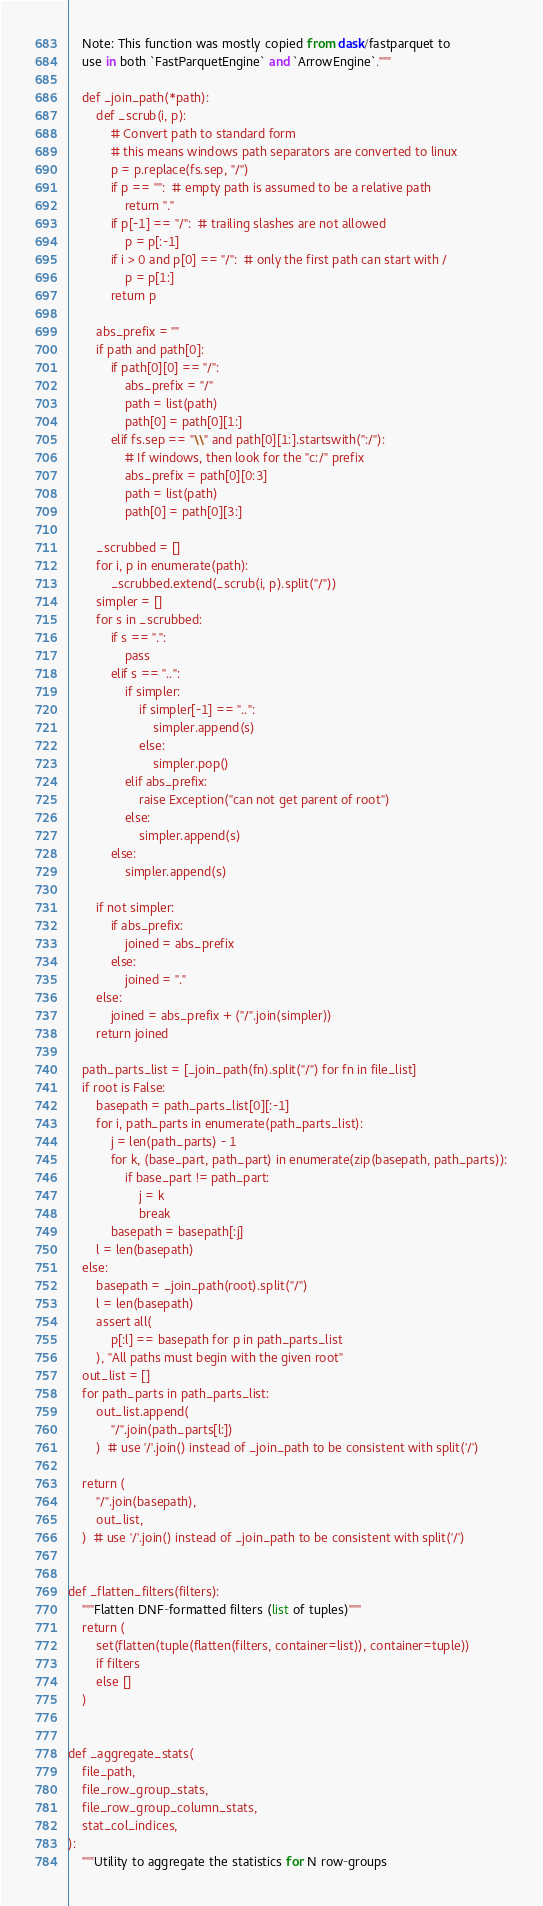Convert code to text. <code><loc_0><loc_0><loc_500><loc_500><_Python_>    Note: This function was mostly copied from dask/fastparquet to
    use in both `FastParquetEngine` and `ArrowEngine`."""

    def _join_path(*path):
        def _scrub(i, p):
            # Convert path to standard form
            # this means windows path separators are converted to linux
            p = p.replace(fs.sep, "/")
            if p == "":  # empty path is assumed to be a relative path
                return "."
            if p[-1] == "/":  # trailing slashes are not allowed
                p = p[:-1]
            if i > 0 and p[0] == "/":  # only the first path can start with /
                p = p[1:]
            return p

        abs_prefix = ""
        if path and path[0]:
            if path[0][0] == "/":
                abs_prefix = "/"
                path = list(path)
                path[0] = path[0][1:]
            elif fs.sep == "\\" and path[0][1:].startswith(":/"):
                # If windows, then look for the "c:/" prefix
                abs_prefix = path[0][0:3]
                path = list(path)
                path[0] = path[0][3:]

        _scrubbed = []
        for i, p in enumerate(path):
            _scrubbed.extend(_scrub(i, p).split("/"))
        simpler = []
        for s in _scrubbed:
            if s == ".":
                pass
            elif s == "..":
                if simpler:
                    if simpler[-1] == "..":
                        simpler.append(s)
                    else:
                        simpler.pop()
                elif abs_prefix:
                    raise Exception("can not get parent of root")
                else:
                    simpler.append(s)
            else:
                simpler.append(s)

        if not simpler:
            if abs_prefix:
                joined = abs_prefix
            else:
                joined = "."
        else:
            joined = abs_prefix + ("/".join(simpler))
        return joined

    path_parts_list = [_join_path(fn).split("/") for fn in file_list]
    if root is False:
        basepath = path_parts_list[0][:-1]
        for i, path_parts in enumerate(path_parts_list):
            j = len(path_parts) - 1
            for k, (base_part, path_part) in enumerate(zip(basepath, path_parts)):
                if base_part != path_part:
                    j = k
                    break
            basepath = basepath[:j]
        l = len(basepath)
    else:
        basepath = _join_path(root).split("/")
        l = len(basepath)
        assert all(
            p[:l] == basepath for p in path_parts_list
        ), "All paths must begin with the given root"
    out_list = []
    for path_parts in path_parts_list:
        out_list.append(
            "/".join(path_parts[l:])
        )  # use '/'.join() instead of _join_path to be consistent with split('/')

    return (
        "/".join(basepath),
        out_list,
    )  # use '/'.join() instead of _join_path to be consistent with split('/')


def _flatten_filters(filters):
    """Flatten DNF-formatted filters (list of tuples)"""
    return (
        set(flatten(tuple(flatten(filters, container=list)), container=tuple))
        if filters
        else []
    )


def _aggregate_stats(
    file_path,
    file_row_group_stats,
    file_row_group_column_stats,
    stat_col_indices,
):
    """Utility to aggregate the statistics for N row-groups</code> 